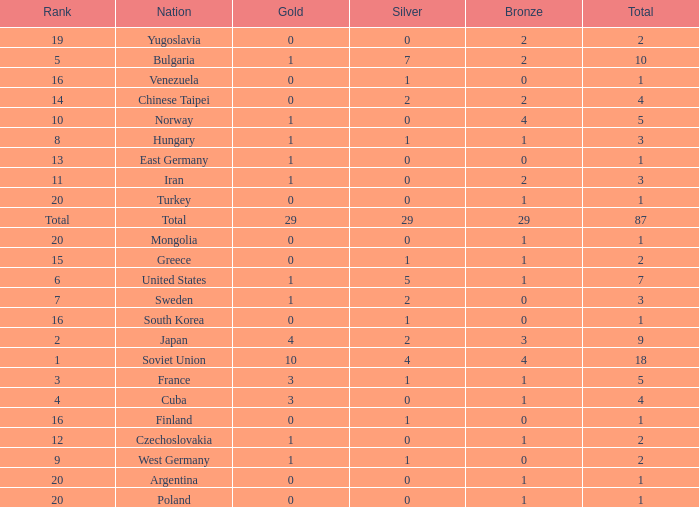What is the total number of gold medals for a ranking of 14? 0.0. 